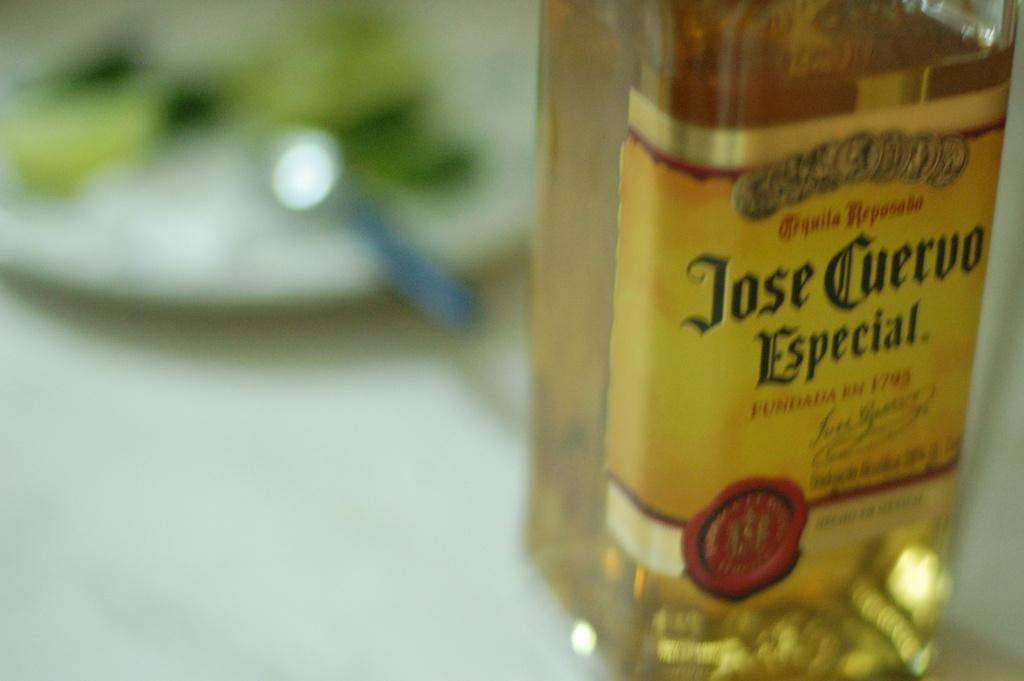<image>
Share a concise interpretation of the image provided. A bottle of alcohol labelled Jose Cuervo Especial sits on the table. 